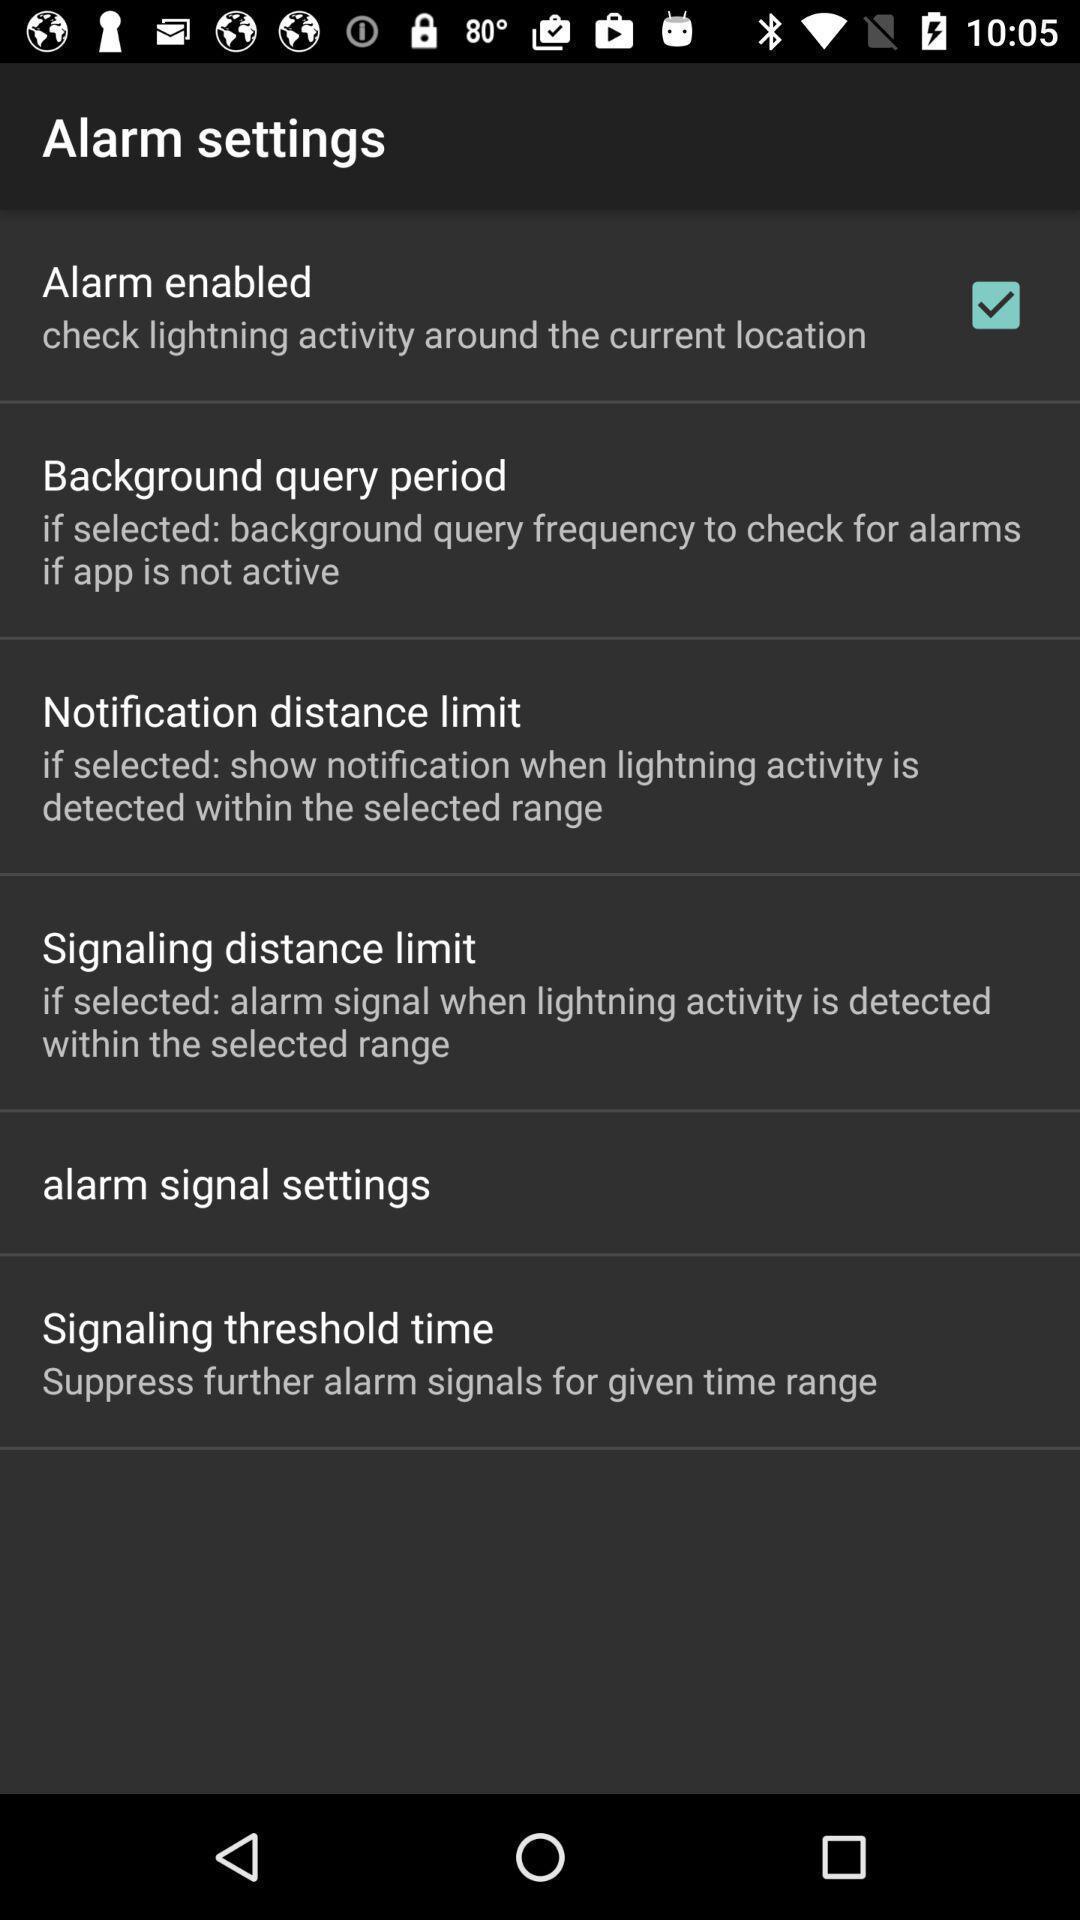Summarize the information in this screenshot. Page displaying the settings of alarms. 